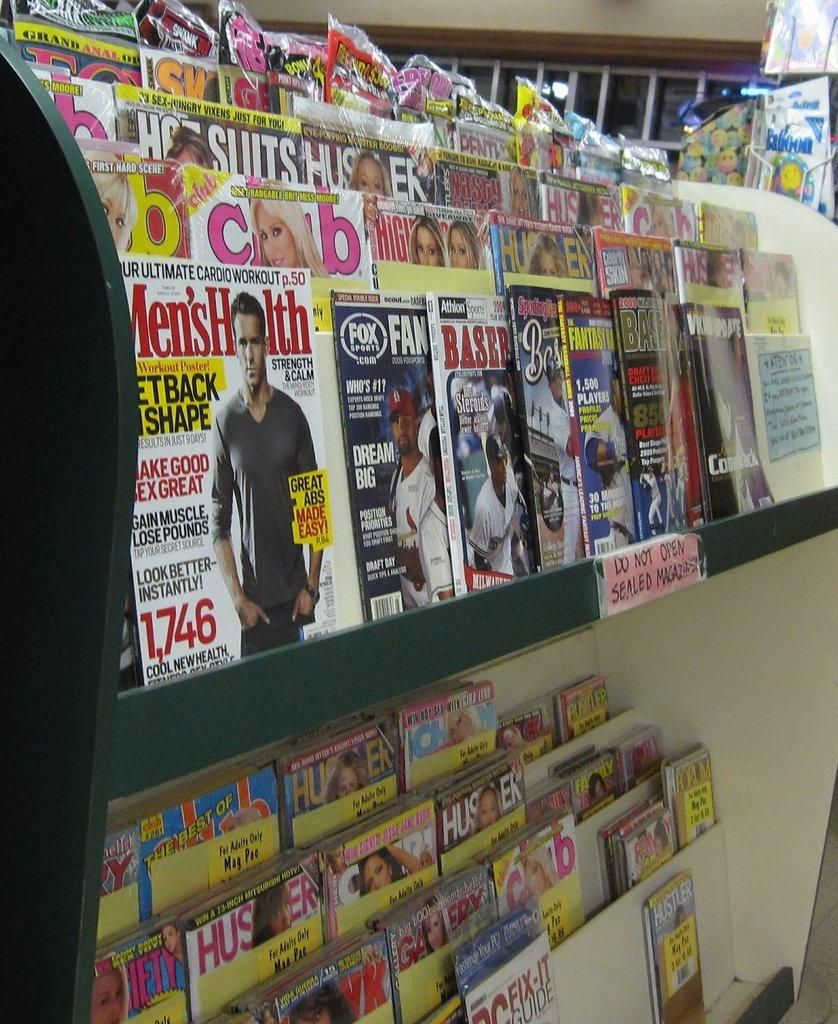What is present on the shelves in the image? There are Maxine's on the shelves in the image. How are the Maxine's arranged on the shelves? The Maxine's are kept on shelves. What is the current status of respect in the image? There is no information about respect in the image, as it only shows Maxine's on shelves. 